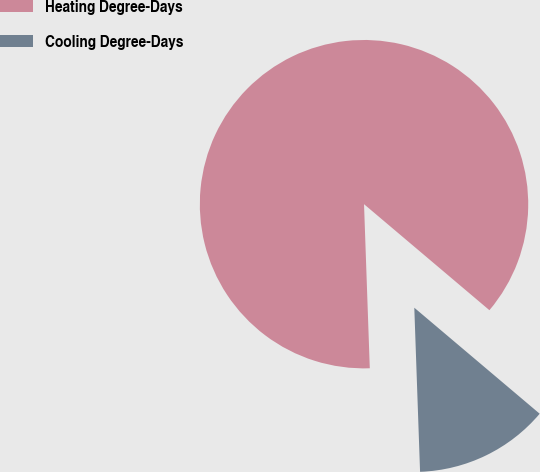Convert chart. <chart><loc_0><loc_0><loc_500><loc_500><pie_chart><fcel>Heating Degree-Days<fcel>Cooling Degree-Days<nl><fcel>86.73%<fcel>13.27%<nl></chart> 